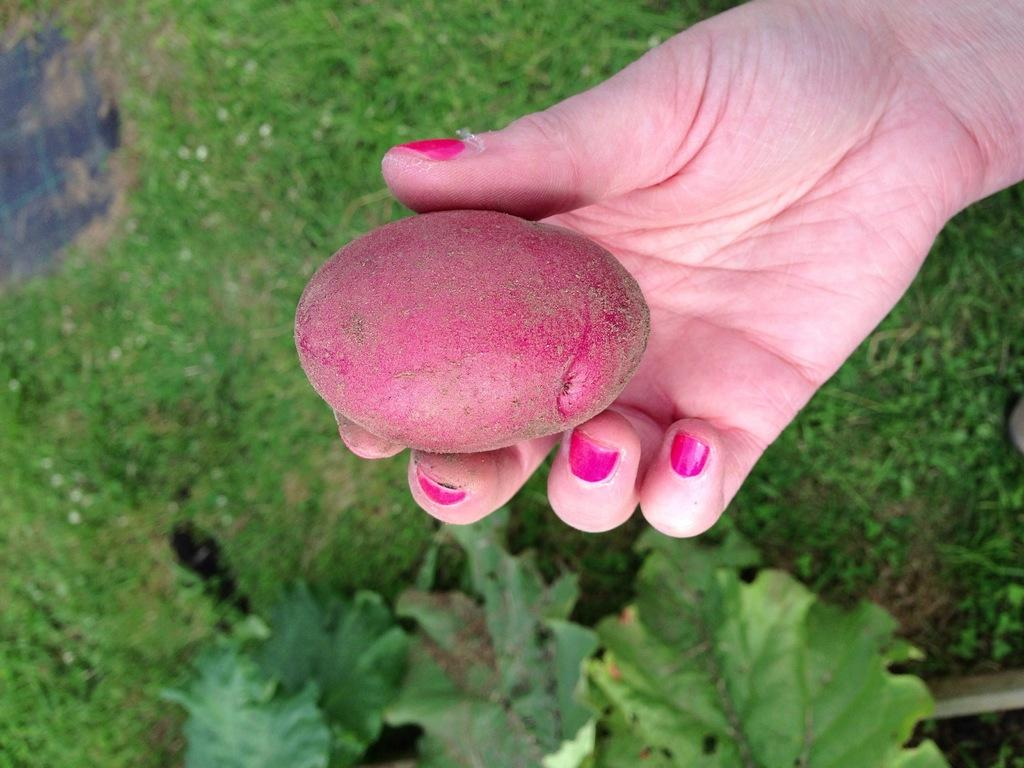What is the main subject in the center of the image? There is a hand in the center of the image. What is on the hand in the image? There is a grape on the hand. What can be seen in the background of the image? There is greenery in the background of the image. How many pears are being held by the girls in the image? There are no girls or pears present in the image; it features a hand with a grape and greenery in the background. 